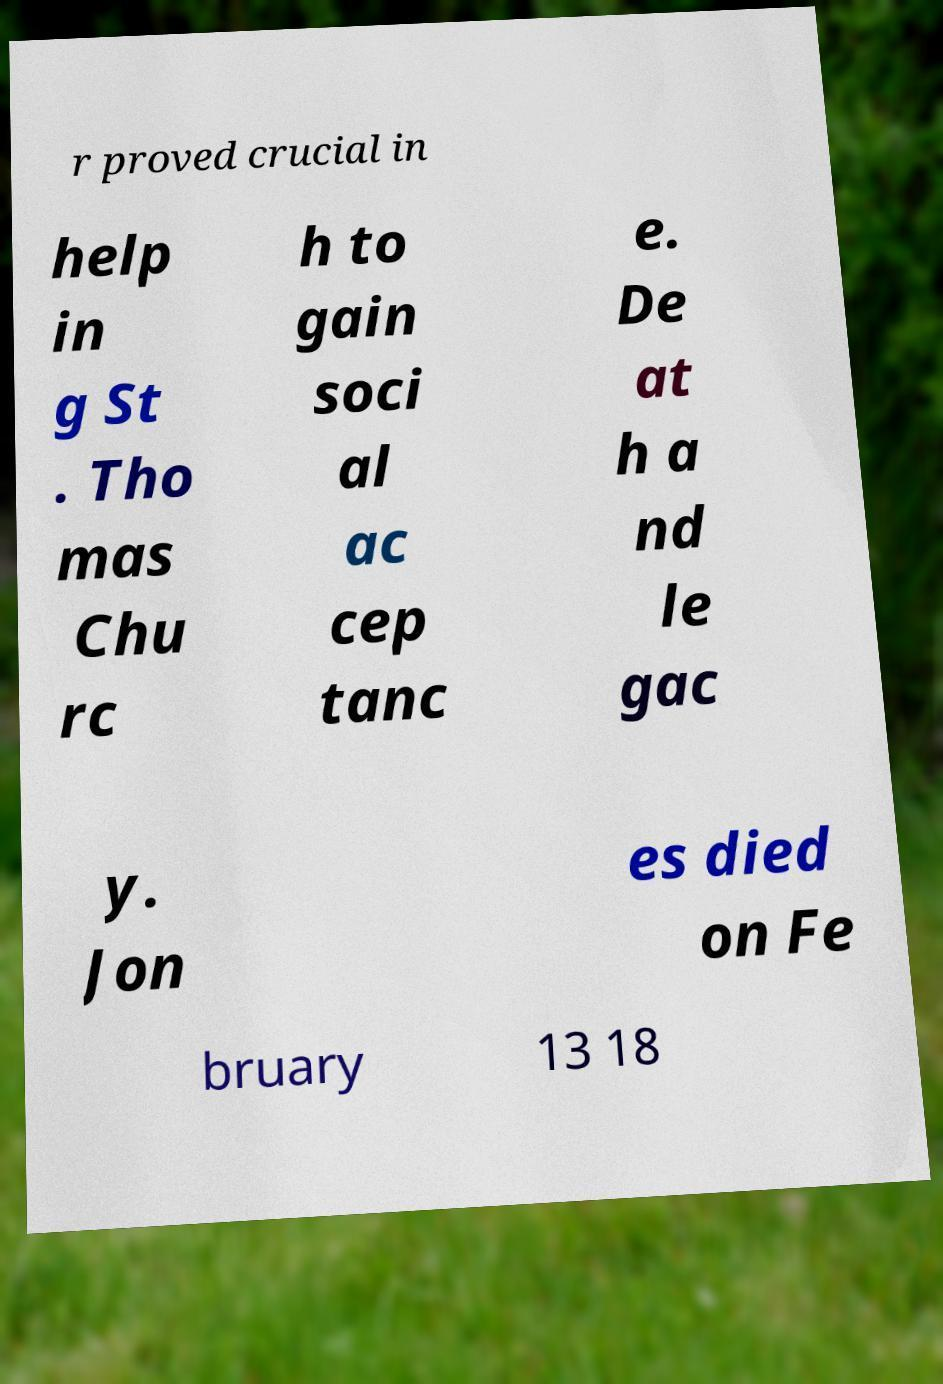What messages or text are displayed in this image? I need them in a readable, typed format. r proved crucial in help in g St . Tho mas Chu rc h to gain soci al ac cep tanc e. De at h a nd le gac y. Jon es died on Fe bruary 13 18 